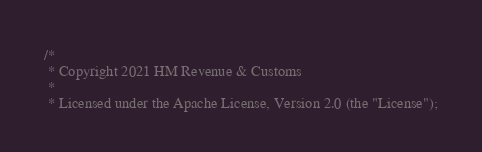Convert code to text. <code><loc_0><loc_0><loc_500><loc_500><_Scala_>/*
 * Copyright 2021 HM Revenue & Customs
 *
 * Licensed under the Apache License, Version 2.0 (the "License");</code> 